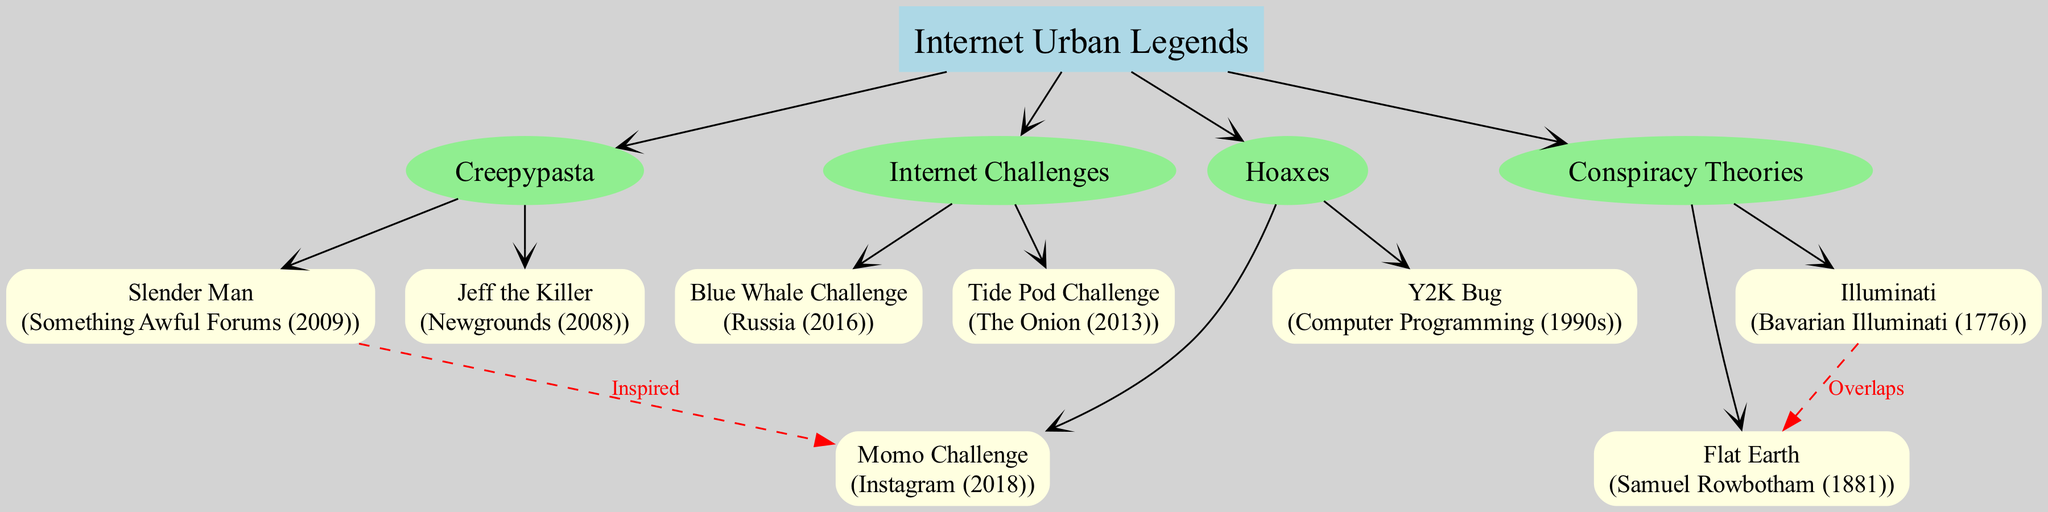What is the root of the family tree? The root, positioned at the top of the diagram, is labeled "Internet Urban Legends."
Answer: Internet Urban Legends How many branches are there in the family tree? There are four main branches stemming from the root, which include Creepypasta, Conspiracy Theories, Internet Challenges, and Hoaxes.
Answer: 4 What year did Jeff the Killer originate? The diagram indicates that Jeff the Killer has its origin in the year 2008, as specified in parentheses next to the name.
Answer: 2008 Which legend is inspired by Slender Man? The diagram shows a dashed red line connecting Slender Man to the Momo Challenge, indicating that Momo Challenge is inspired by Slender Man.
Answer: Momo Challenge Which two urban legends overlap according to the connections in the diagram? The diagram depicts a relationship between Illuminati and Flat Earth, where it is stated they overlap, shown by the dashed red line connecting them.
Answer: Illuminati and Flat Earth Name one internet challenge from the family tree. From the diagram, there are two challenges listed—Blue Whale Challenge and Tide Pod Challenge. Either one can be an acceptable answer.
Answer: Blue Whale Challenge What type of node is "Creepypasta"? In the diagram, Creepypasta is depicted as a branch node, which is represented as an ellipse filled with light green color.
Answer: Branch node How did the Y2K Bug originate? The origin of the Y2K Bug is described in the diagram as "Computer Programming (1990s)," indicating where this myth started.
Answer: Computer Programming (1990s) What color represents the root node in the diagram? The root node is filled with light blue color, which is specified in the visual attributes described for the root.
Answer: Light blue 